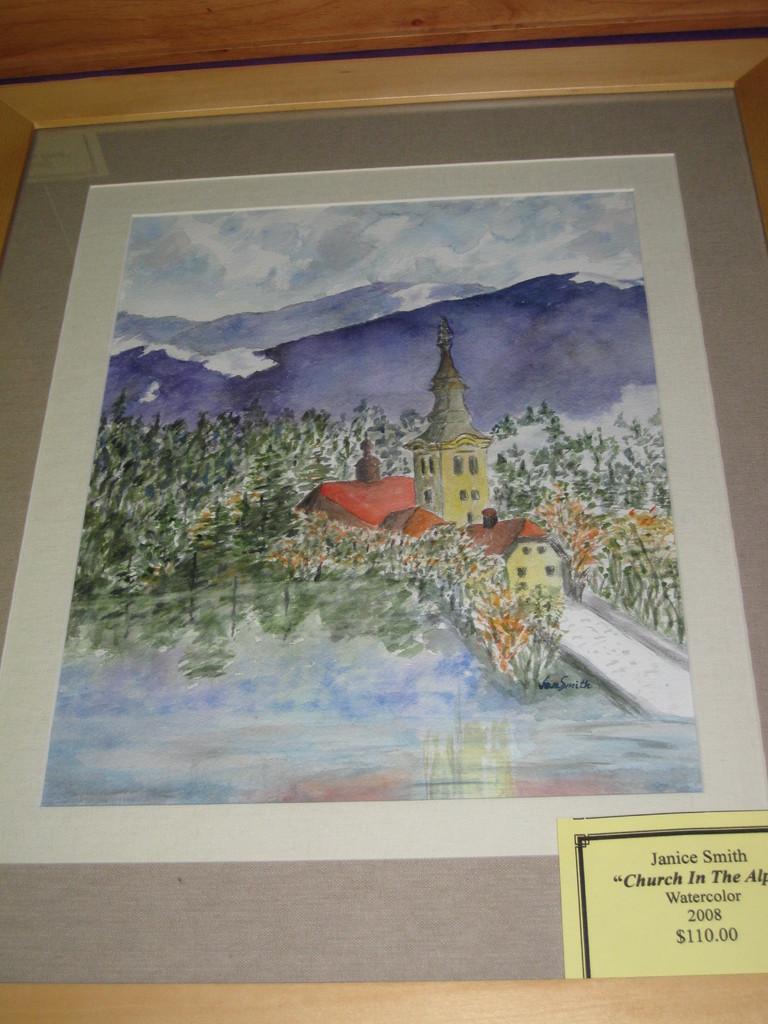Can you describe this image briefly? In the picture I can see a painting. In the painting I can see trees, a building, mountains, the sky, the water and some other things. I can also see something written on an object. 